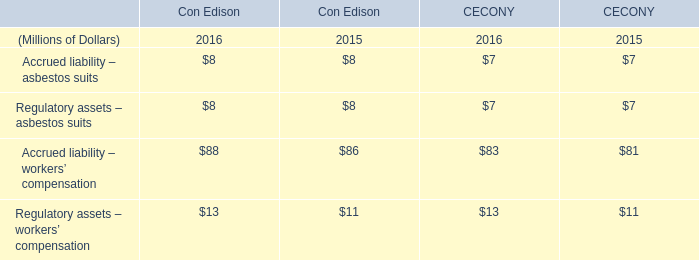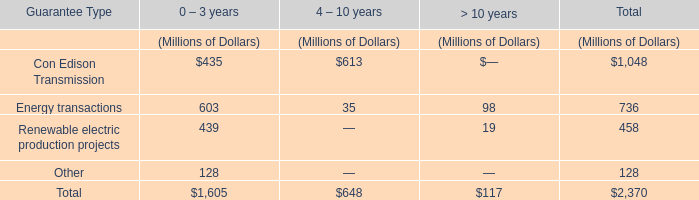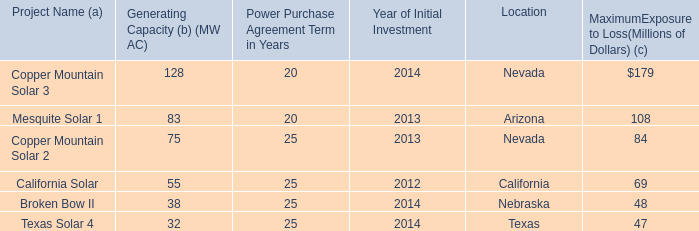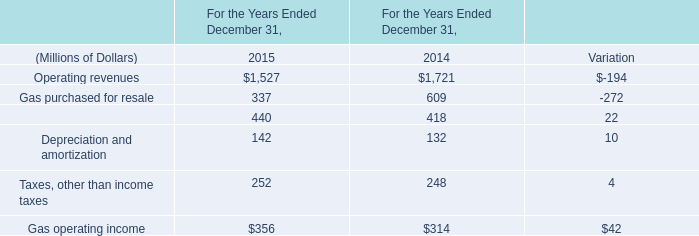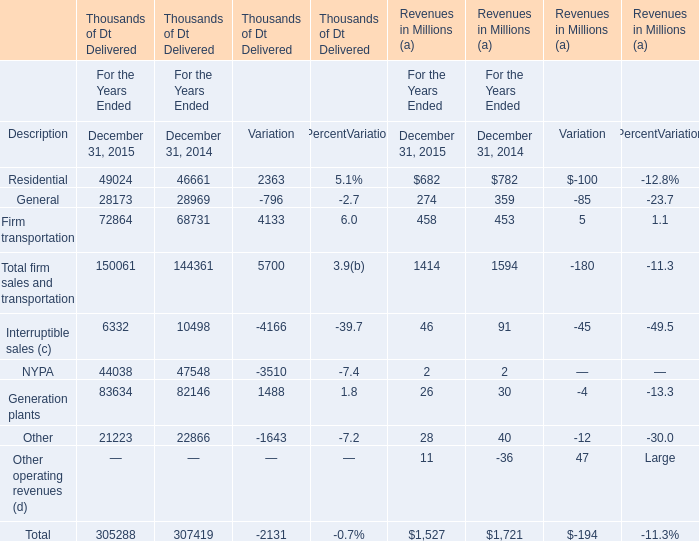What is the sum of Operating revenues in the range of 0 and 2000 in 2015? (in million) 
Answer: 1527. 